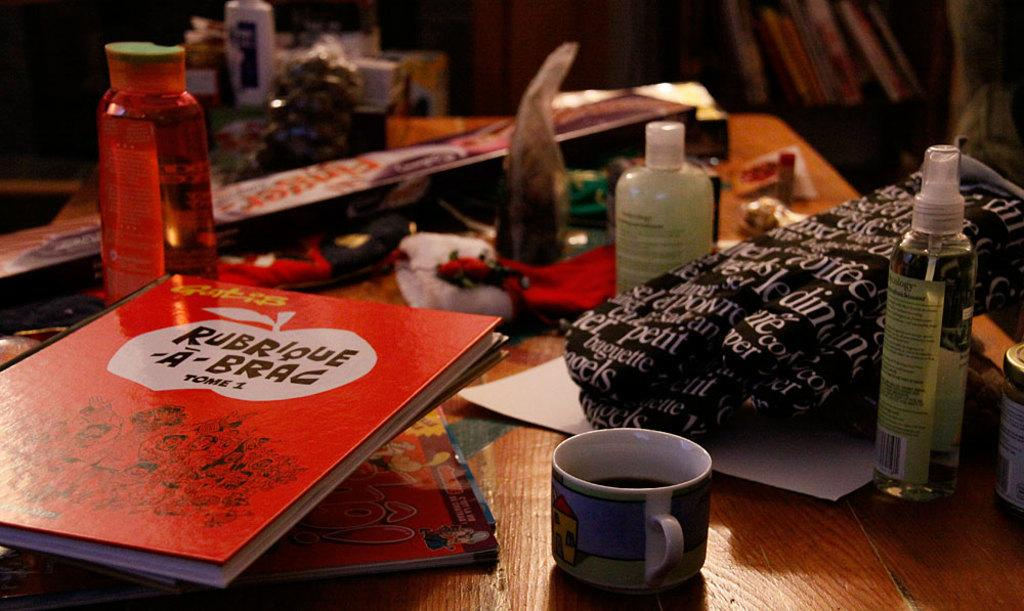<image>
Relay a brief, clear account of the picture shown. a cluttered desk with a red book titled "Rubrique a-brac" 